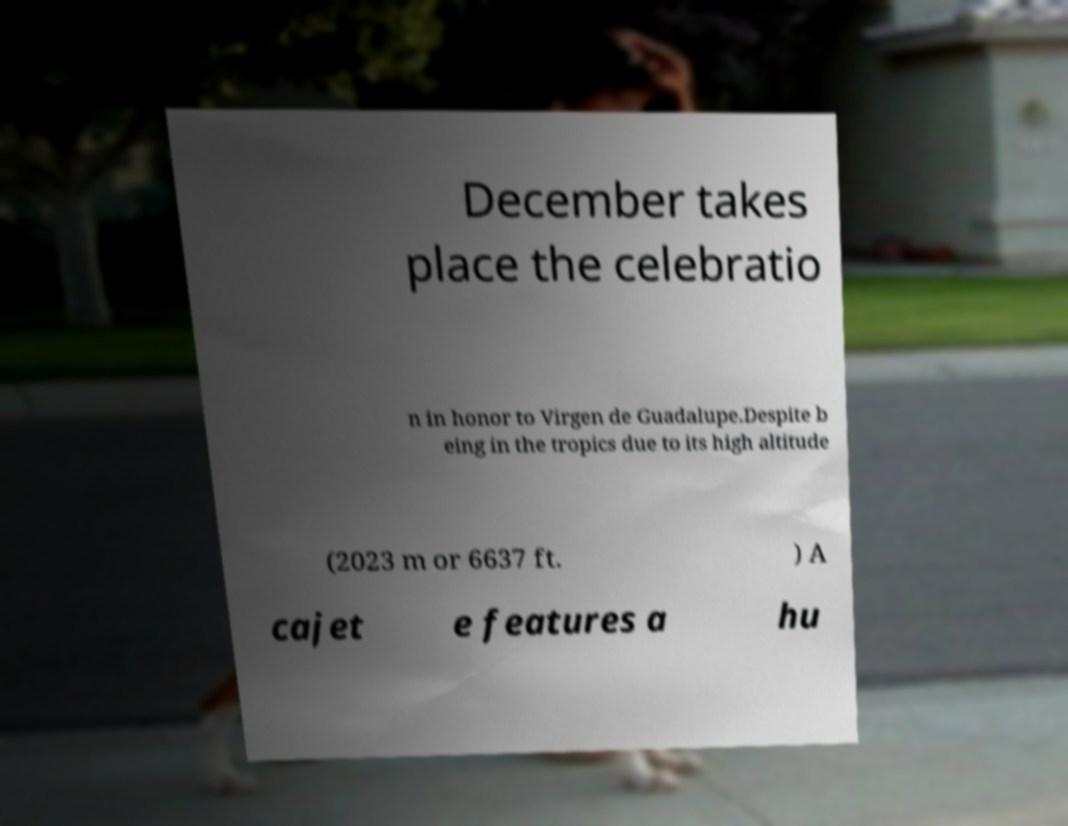Please read and relay the text visible in this image. What does it say? December takes place the celebratio n in honor to Virgen de Guadalupe.Despite b eing in the tropics due to its high altitude (2023 m or 6637 ft. ) A cajet e features a hu 